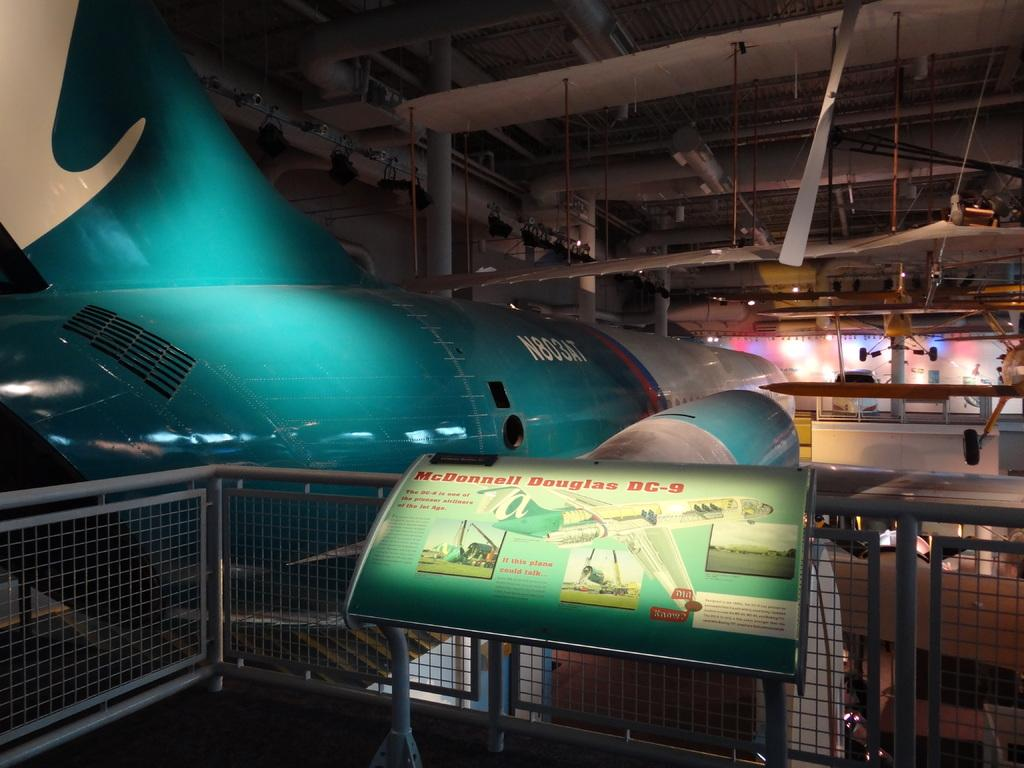<image>
Render a clear and concise summary of the photo. information about mcdonald douglas is shown on a plaque 